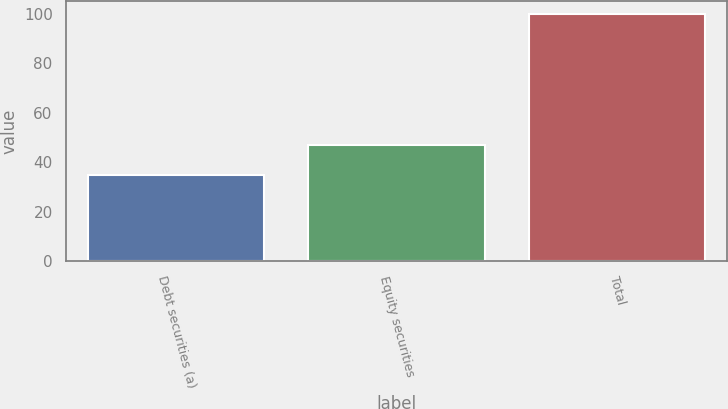Convert chart. <chart><loc_0><loc_0><loc_500><loc_500><bar_chart><fcel>Debt securities (a)<fcel>Equity securities<fcel>Total<nl><fcel>35<fcel>47<fcel>100<nl></chart> 